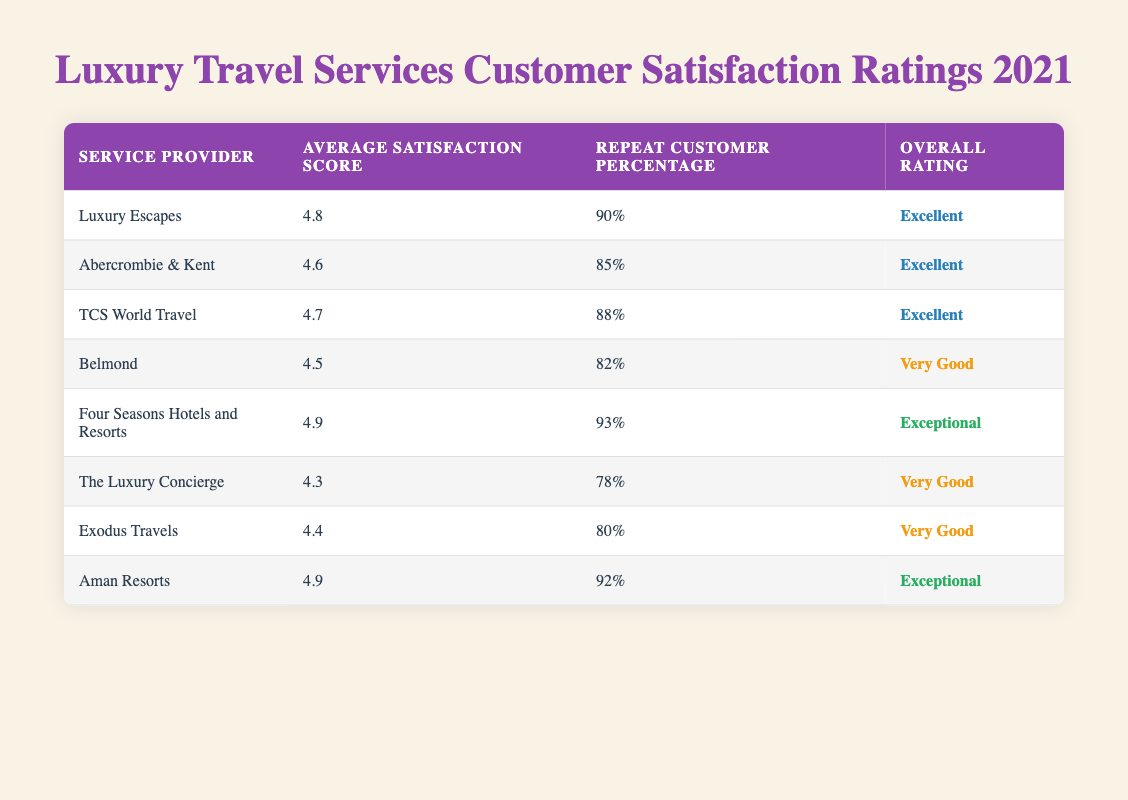What is the average satisfaction score of Four Seasons Hotels and Resorts? From the table, the Average Satisfaction Score for Four Seasons Hotels and Resorts is listed under its entry, which is 4.9.
Answer: 4.9 What percentage of repeat customers does Aman Resorts have? The table shows that Aman Resorts has a Repeat Customer Percentage listed as 92%.
Answer: 92% Which service provider has the lowest average satisfaction score? By reviewing the Average Satisfaction Score for all service providers, The Luxury Concierge has the lowest score at 4.3.
Answer: The Luxury Concierge Is Belmond rated as Excellent? The Overall Rating for Belmond is listed as "Very Good," not "Excellent," so the answer is no.
Answer: No What is the difference in repeat customer percentage between Luxury Escapes and Exodus Travels? The Repeat Customer Percentage for Luxury Escapes is 90% while for Exodus Travels it is 80%. The difference is calculated as 90% - 80% = 10%.
Answer: 10% Which service provider has both a high satisfaction score (4.8 or above) and a high repeat customer percentage (above 90%)? By examining the table, we see that Four Seasons Hotels and Resorts (4.9, 93%) and Aman Resorts (4.9, 92%) meet both criteria, so they are the answers.
Answer: Four Seasons Hotels and Resorts, Aman Resorts Is it true that TCS World Travel has a lower average satisfaction score than Abercrombie & Kent? Checking the scores: TCS World Travel has a score of 4.7 while Abercrombie & Kent has a score of 4.6. Since 4.7 is higher than 4.6, the statement is false.
Answer: No What overall ratings do the service providers with an average satisfaction score of 4.4 or higher have? The service providers with scores of 4.4 or higher include Luxury Escapes (Excellent), Abercrombie & Kent (Excellent), TCS World Travel (Excellent), Four Seasons Hotels and Resorts (Exceptional), Aman Resorts (Exceptional), and Exodus Travels (Very Good). The distinct overall ratings among them are Excellent, Exceptional, and Very Good.
Answer: Excellent, Exceptional, Very Good 